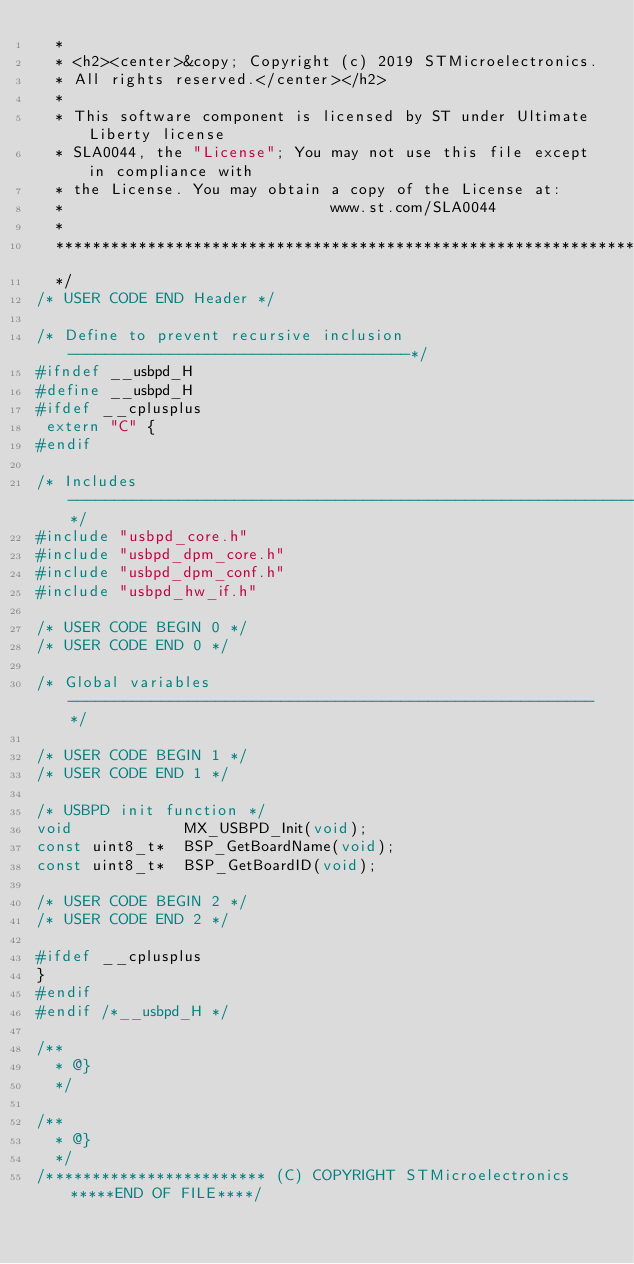Convert code to text. <code><loc_0><loc_0><loc_500><loc_500><_C_>  *
  * <h2><center>&copy; Copyright (c) 2019 STMicroelectronics.
  * All rights reserved.</center></h2>
  *
  * This software component is licensed by ST under Ultimate Liberty license
  * SLA0044, the "License"; You may not use this file except in compliance with
  * the License. You may obtain a copy of the License at:
  *                             www.st.com/SLA0044
  *
  ******************************************************************************
  */
/* USER CODE END Header */

/* Define to prevent recursive inclusion -------------------------------------*/
#ifndef __usbpd_H
#define __usbpd_H
#ifdef __cplusplus
 extern "C" {
#endif

/* Includes ------------------------------------------------------------------*/
#include "usbpd_core.h"
#include "usbpd_dpm_core.h"
#include "usbpd_dpm_conf.h"
#include "usbpd_hw_if.h"

/* USER CODE BEGIN 0 */
/* USER CODE END 0 */

/* Global variables ---------------------------------------------------------*/

/* USER CODE BEGIN 1 */
/* USER CODE END 1 */

/* USBPD init function */
void            MX_USBPD_Init(void);
const uint8_t*  BSP_GetBoardName(void);
const uint8_t*  BSP_GetBoardID(void);

/* USER CODE BEGIN 2 */
/* USER CODE END 2 */

#ifdef __cplusplus
}
#endif
#endif /*__usbpd_H */

/**
  * @}
  */

/**
  * @}
  */
/************************ (C) COPYRIGHT STMicroelectronics *****END OF FILE****/
</code> 